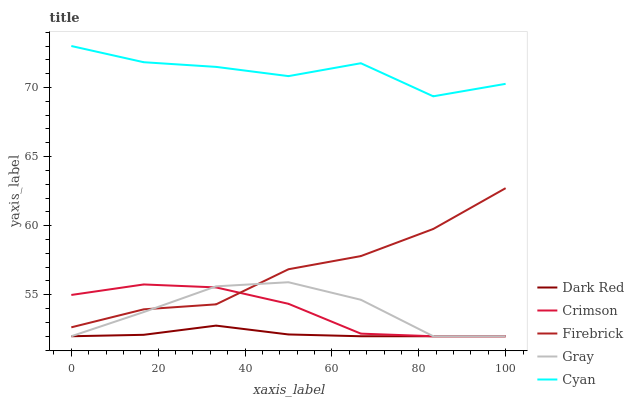Does Dark Red have the minimum area under the curve?
Answer yes or no. Yes. Does Cyan have the maximum area under the curve?
Answer yes or no. Yes. Does Firebrick have the minimum area under the curve?
Answer yes or no. No. Does Firebrick have the maximum area under the curve?
Answer yes or no. No. Is Dark Red the smoothest?
Answer yes or no. Yes. Is Cyan the roughest?
Answer yes or no. Yes. Is Firebrick the smoothest?
Answer yes or no. No. Is Firebrick the roughest?
Answer yes or no. No. Does Crimson have the lowest value?
Answer yes or no. Yes. Does Firebrick have the lowest value?
Answer yes or no. No. Does Cyan have the highest value?
Answer yes or no. Yes. Does Firebrick have the highest value?
Answer yes or no. No. Is Firebrick less than Cyan?
Answer yes or no. Yes. Is Cyan greater than Gray?
Answer yes or no. Yes. Does Firebrick intersect Crimson?
Answer yes or no. Yes. Is Firebrick less than Crimson?
Answer yes or no. No. Is Firebrick greater than Crimson?
Answer yes or no. No. Does Firebrick intersect Cyan?
Answer yes or no. No. 